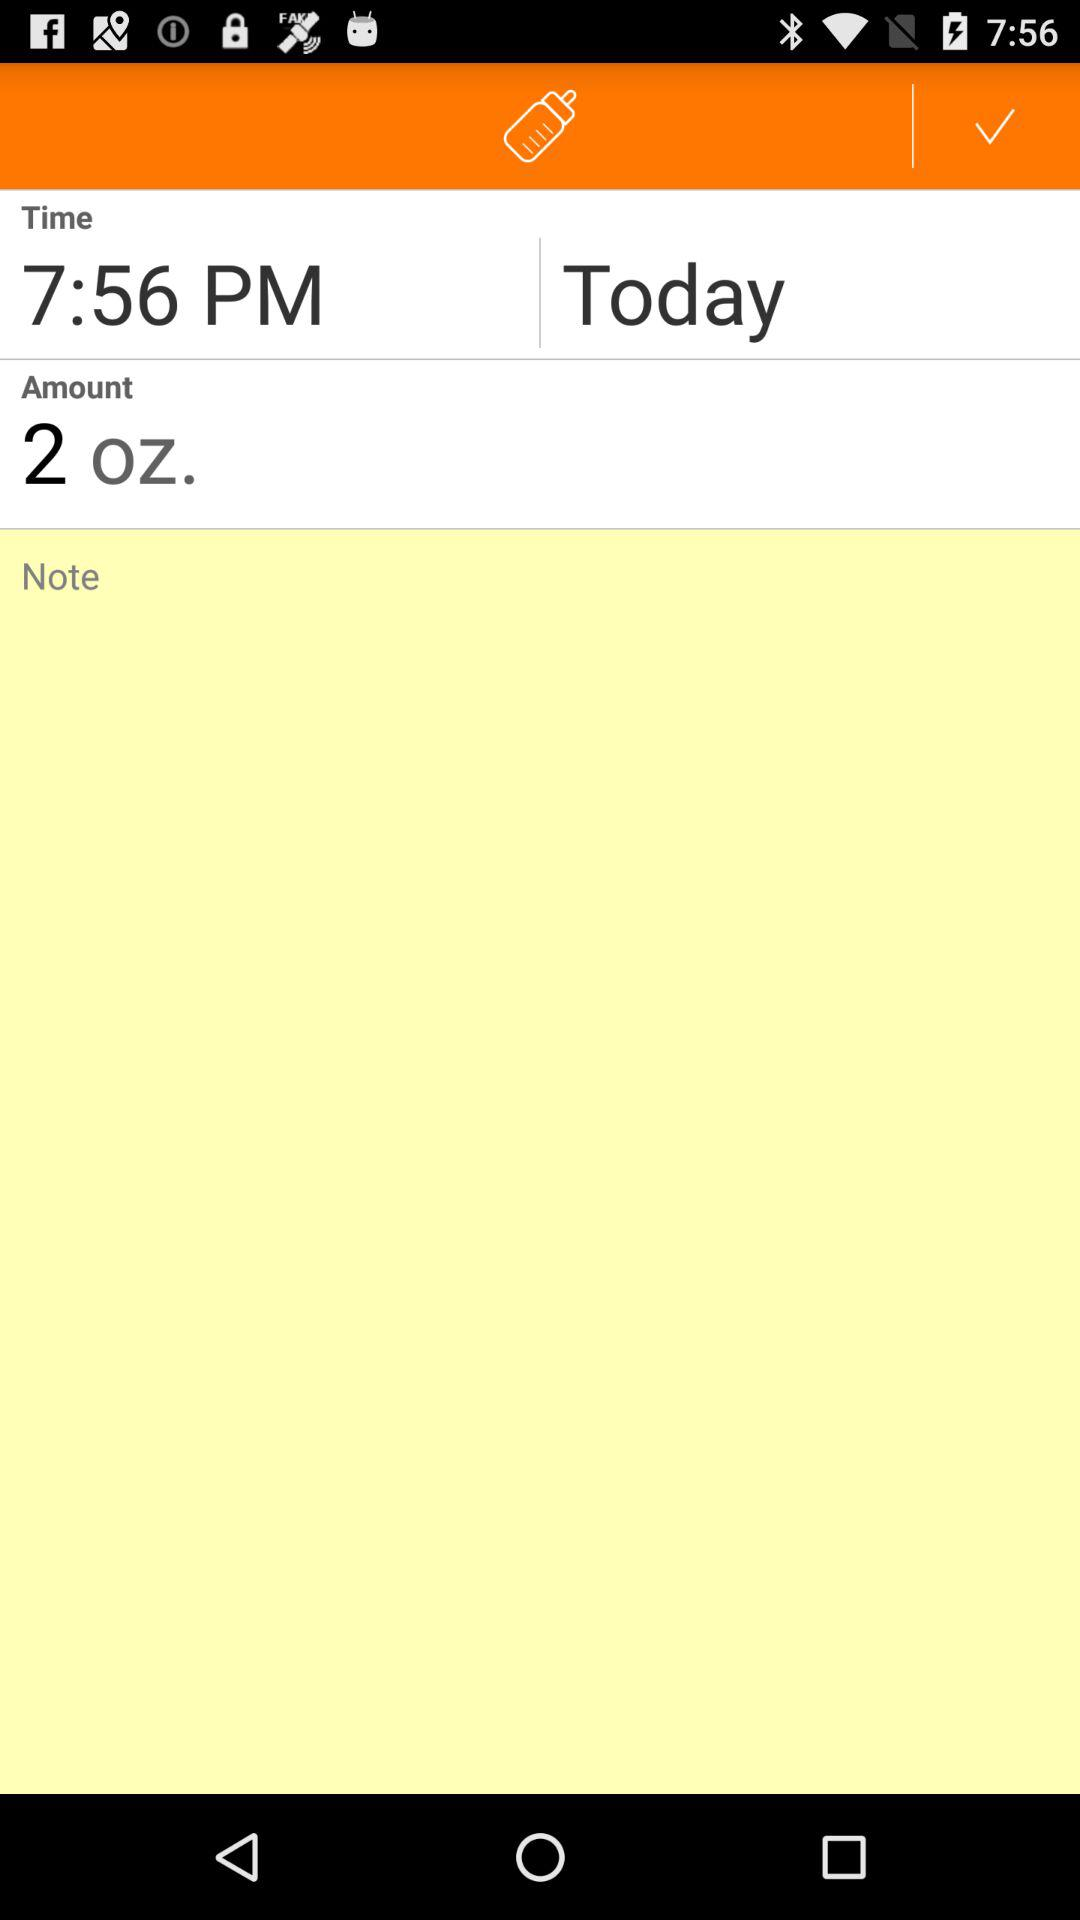What is the amount in oz? The amount in oz is 2. 